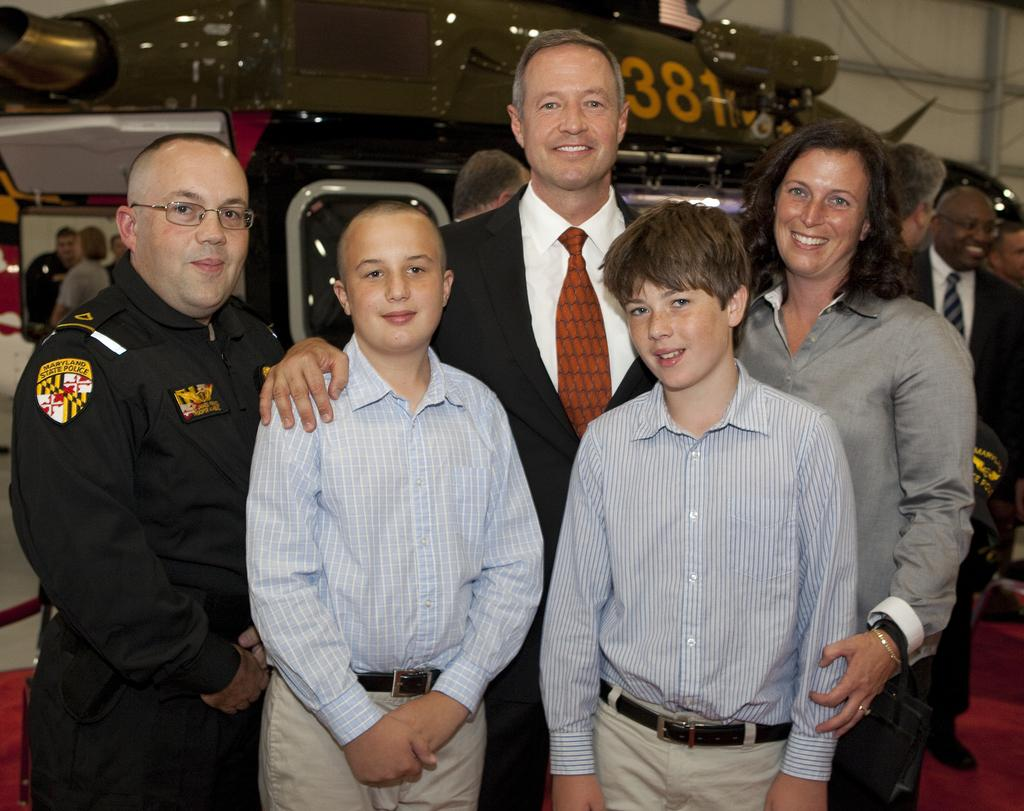What is happening in the center of the image? There are people standing in the center of the image. Can you describe the people behind them? There are other people behind the people standing in the center of the image. What type of yarn is being used by the people in the image? There is no yarn present in the image; it only shows people standing in the center and behind them. What kind of needlework is being done on the canvas in the image? There is no canvas or needlework present in the image. 